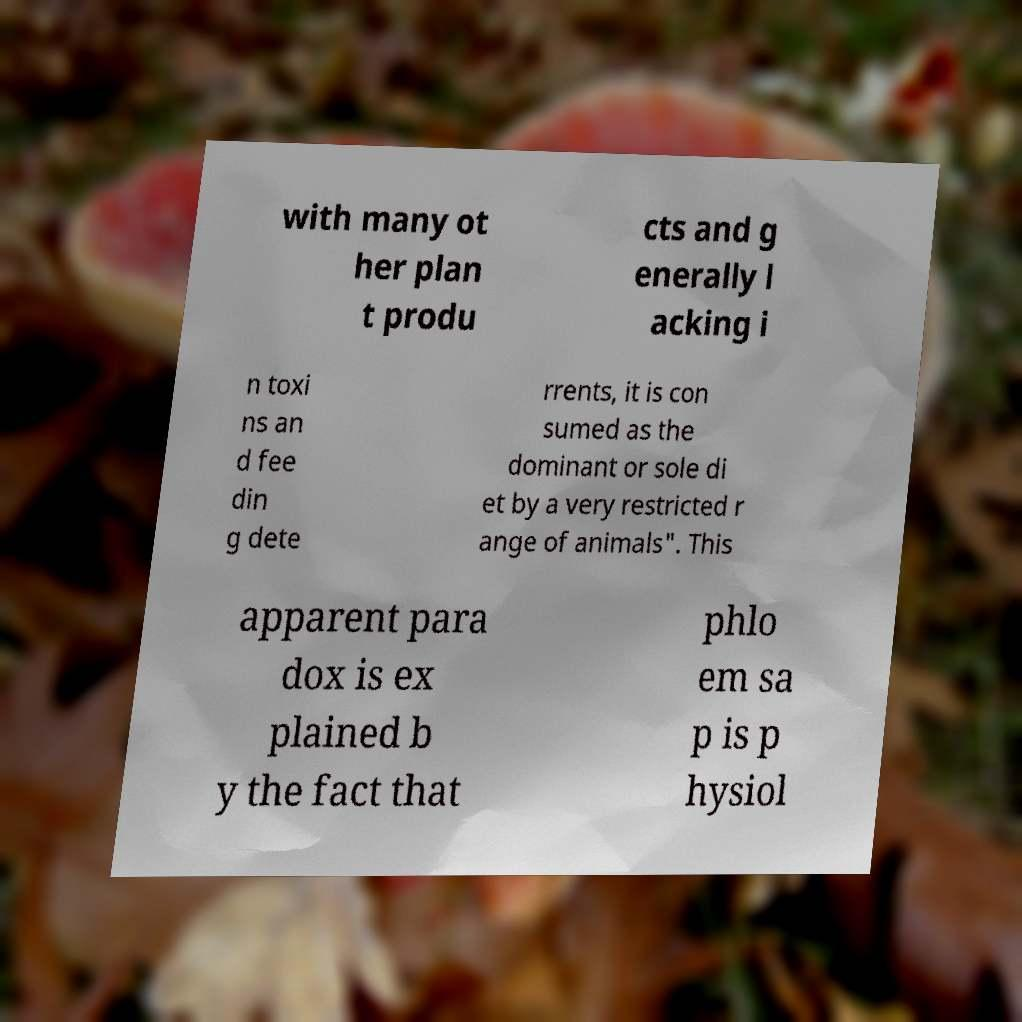What messages or text are displayed in this image? I need them in a readable, typed format. with many ot her plan t produ cts and g enerally l acking i n toxi ns an d fee din g dete rrents, it is con sumed as the dominant or sole di et by a very restricted r ange of animals". This apparent para dox is ex plained b y the fact that phlo em sa p is p hysiol 